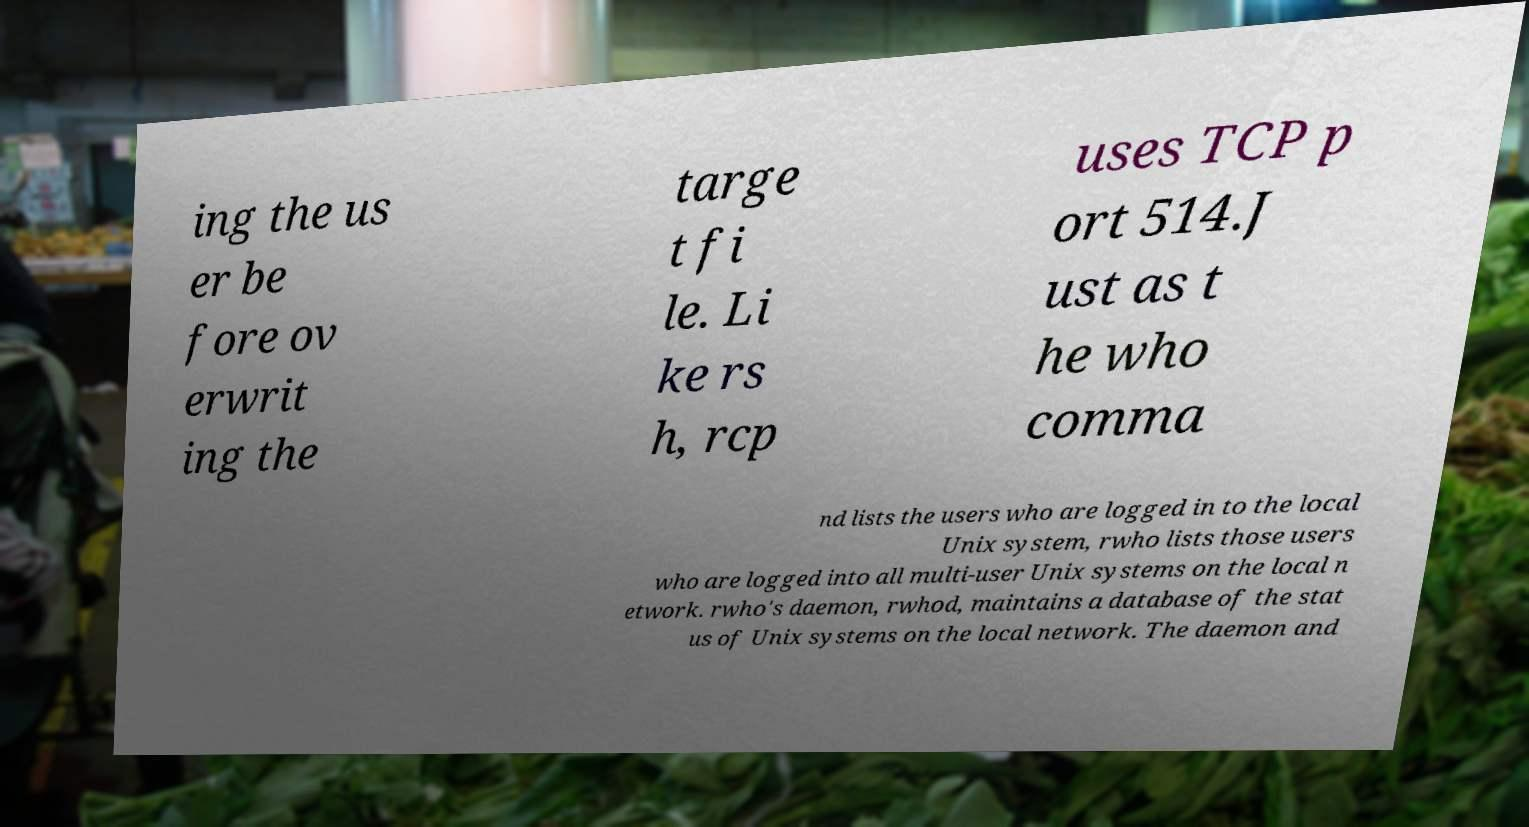Could you assist in decoding the text presented in this image and type it out clearly? ing the us er be fore ov erwrit ing the targe t fi le. Li ke rs h, rcp uses TCP p ort 514.J ust as t he who comma nd lists the users who are logged in to the local Unix system, rwho lists those users who are logged into all multi-user Unix systems on the local n etwork. rwho's daemon, rwhod, maintains a database of the stat us of Unix systems on the local network. The daemon and 